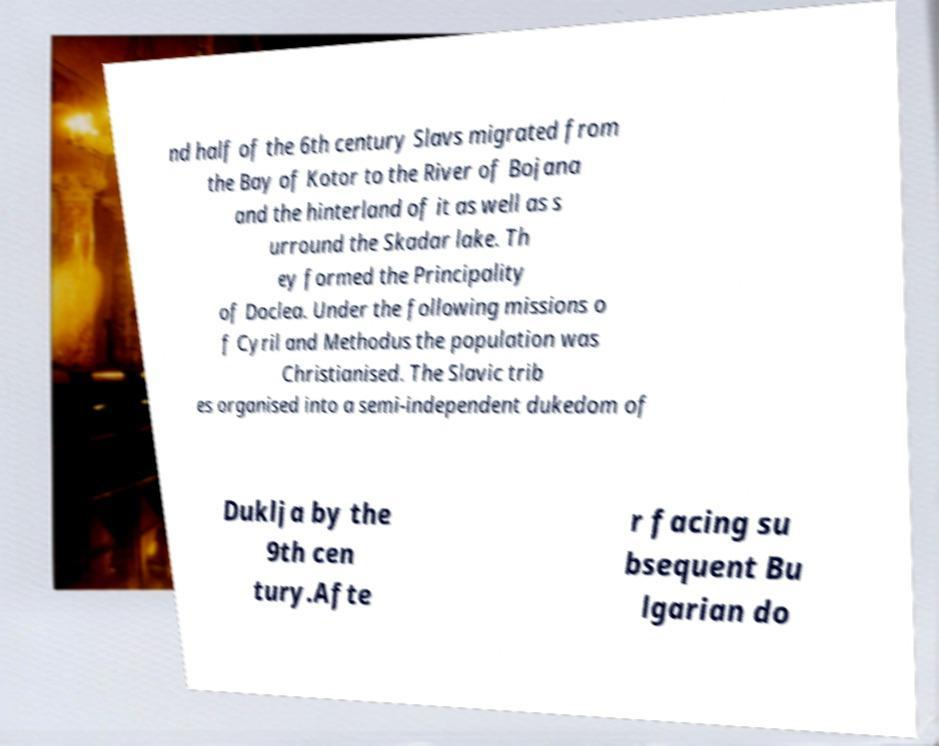I need the written content from this picture converted into text. Can you do that? nd half of the 6th century Slavs migrated from the Bay of Kotor to the River of Bojana and the hinterland of it as well as s urround the Skadar lake. Th ey formed the Principality of Doclea. Under the following missions o f Cyril and Methodus the population was Christianised. The Slavic trib es organised into a semi-independent dukedom of Duklja by the 9th cen tury.Afte r facing su bsequent Bu lgarian do 